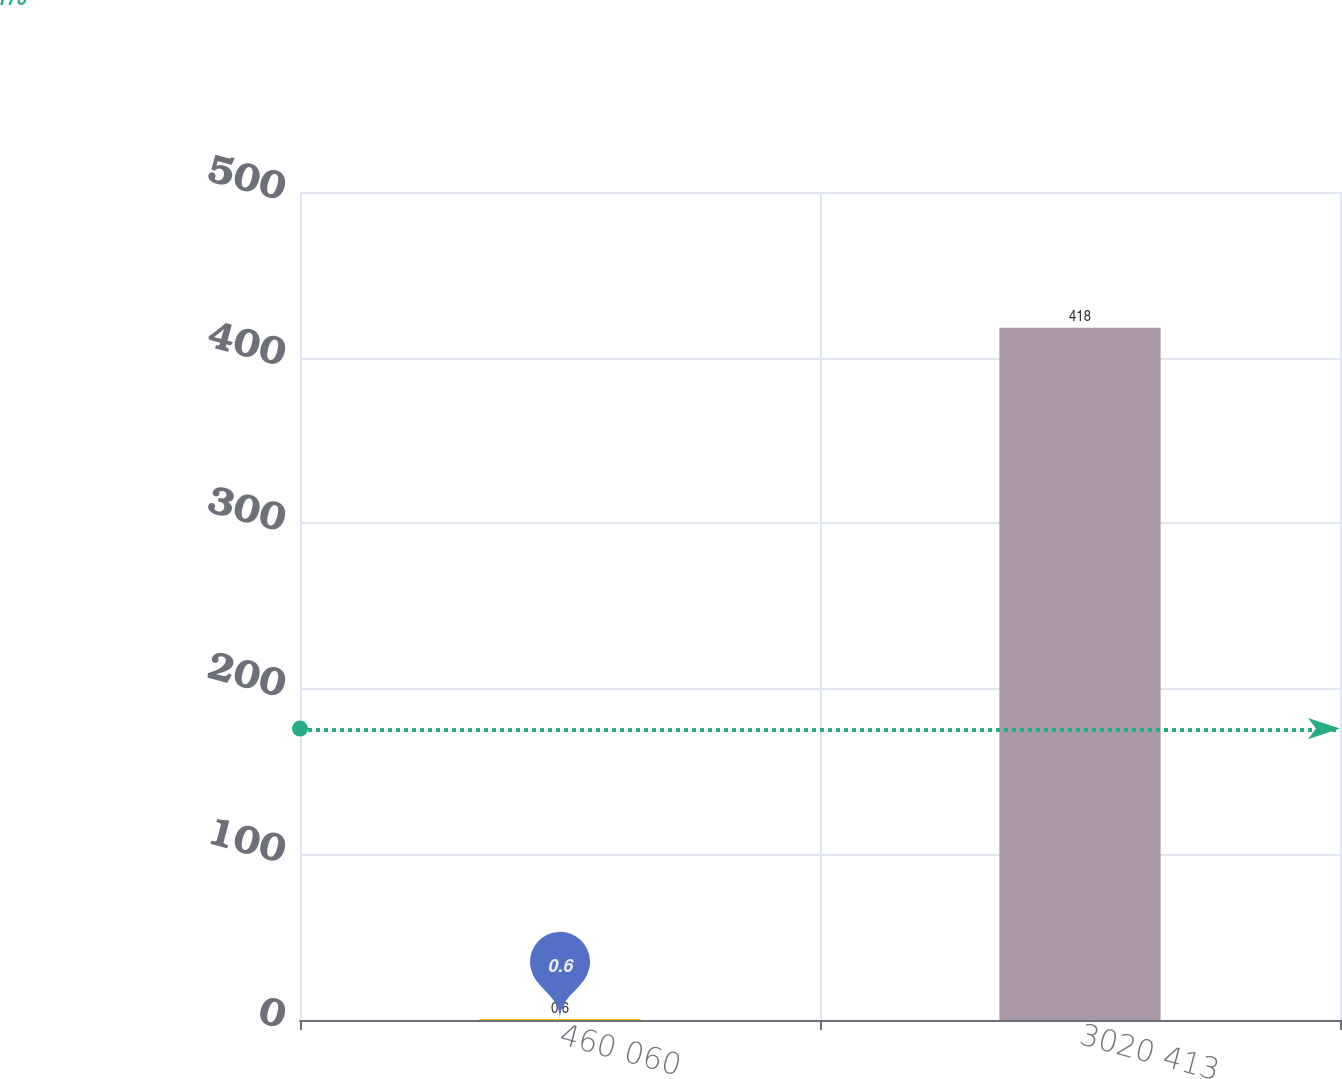<chart> <loc_0><loc_0><loc_500><loc_500><bar_chart><fcel>460 060<fcel>3020 413<nl><fcel>0.6<fcel>418<nl></chart> 